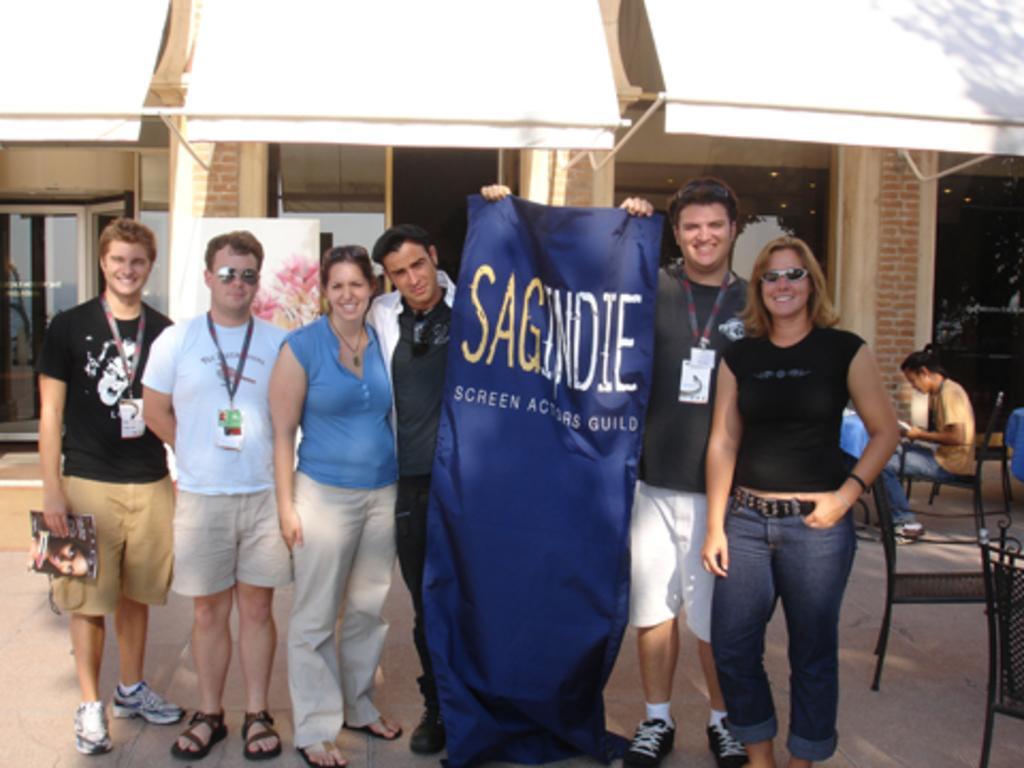Describe this image in one or two sentences. There are many people standing. Two people are holding a banner with something written on that. Some are wearing tags. Person on the left side is holding a book. On the right side there are chairs. In the back a lady is sitting on a chair. Also there is a building in the background. 